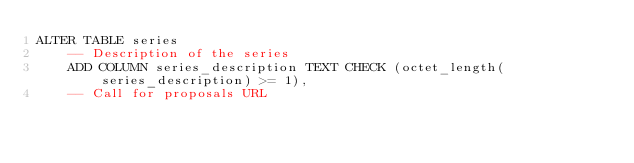Convert code to text. <code><loc_0><loc_0><loc_500><loc_500><_SQL_>ALTER TABLE series
    -- Description of the series
    ADD COLUMN series_description TEXT CHECK (octet_length(series_description) >= 1),
    -- Call for proposals URL</code> 